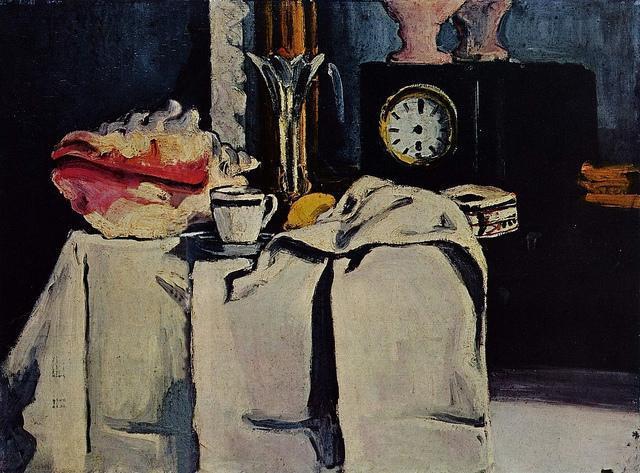How many pink spoons are there?
Give a very brief answer. 0. 